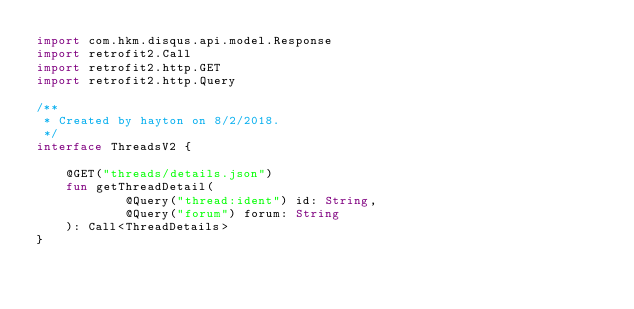<code> <loc_0><loc_0><loc_500><loc_500><_Kotlin_>import com.hkm.disqus.api.model.Response
import retrofit2.Call
import retrofit2.http.GET
import retrofit2.http.Query

/**
 * Created by hayton on 8/2/2018.
 */
interface ThreadsV2 {

    @GET("threads/details.json")
    fun getThreadDetail(
            @Query("thread:ident") id: String,
            @Query("forum") forum: String
    ): Call<ThreadDetails>
}</code> 